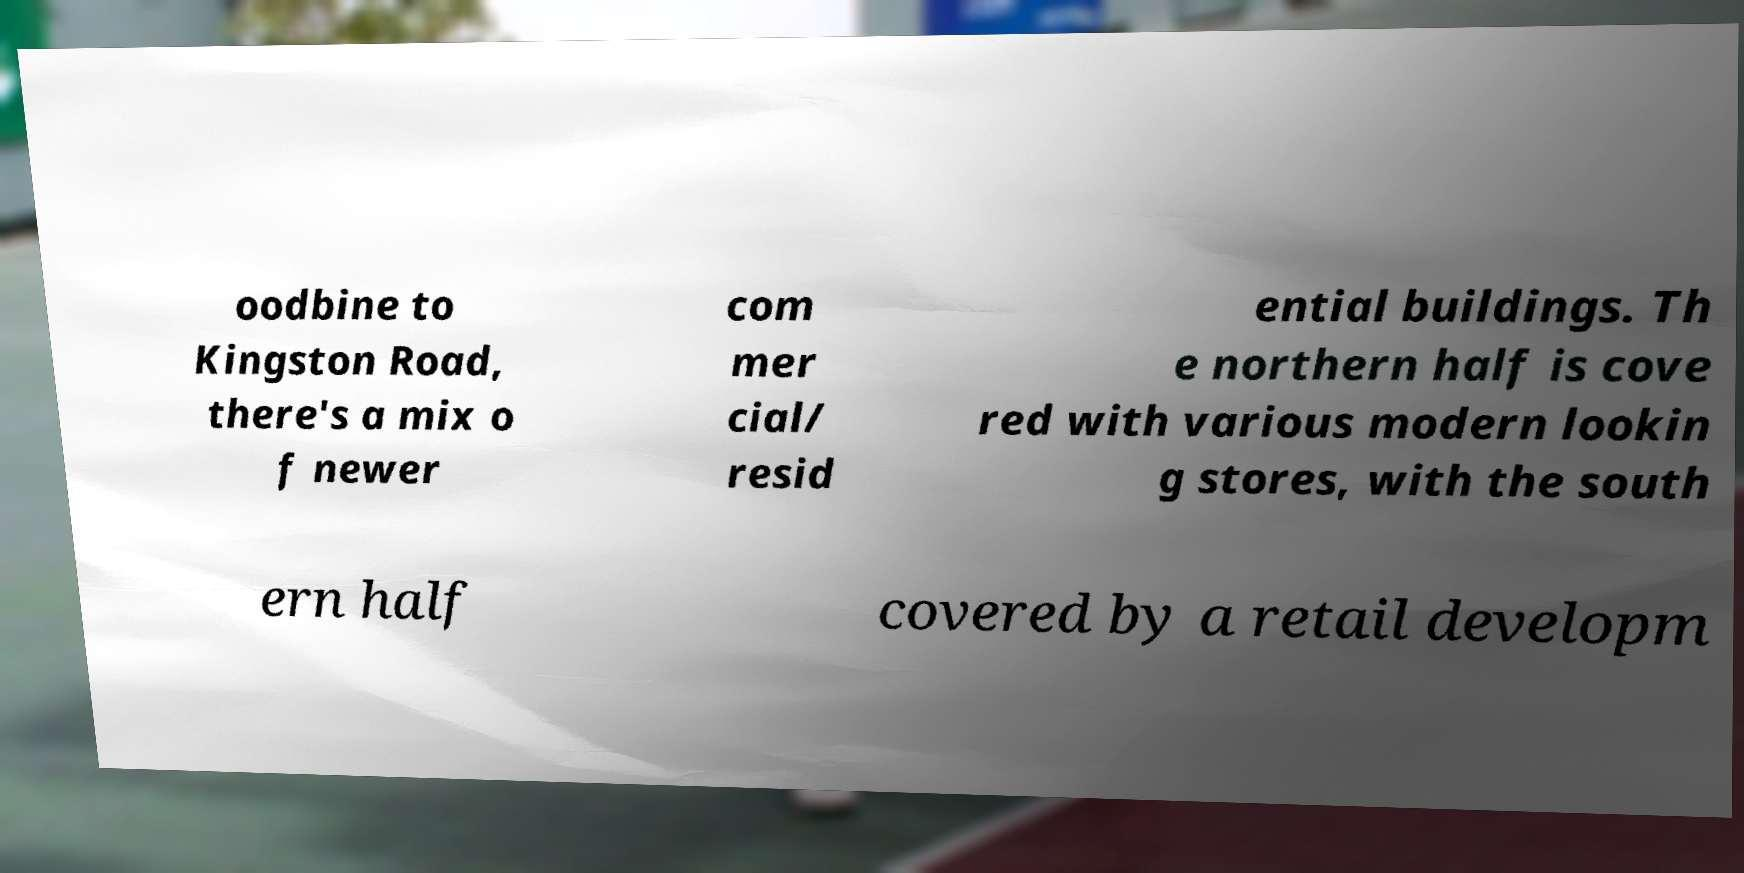Could you assist in decoding the text presented in this image and type it out clearly? oodbine to Kingston Road, there's a mix o f newer com mer cial/ resid ential buildings. Th e northern half is cove red with various modern lookin g stores, with the south ern half covered by a retail developm 